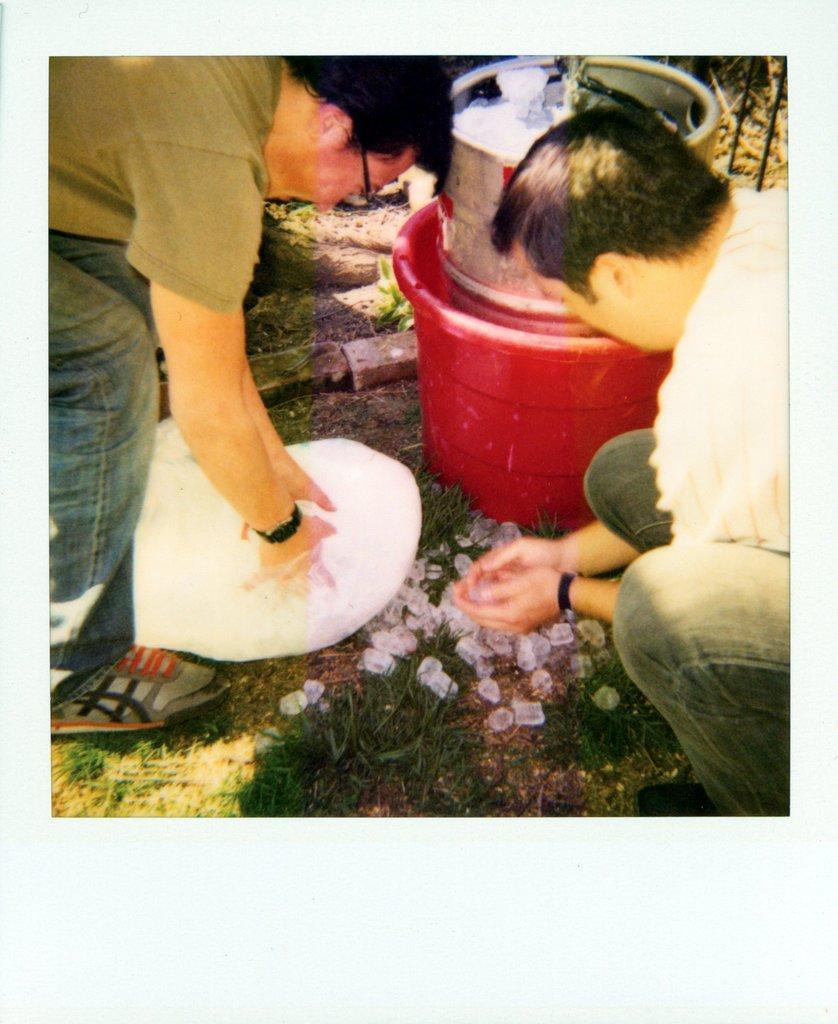How would you summarize this image in a sentence or two? In this image we can see two persons, they are holding ice cubes, there are ice cubes in a bowl, there is a bucket, and some other bowls, also we can see the grass. 